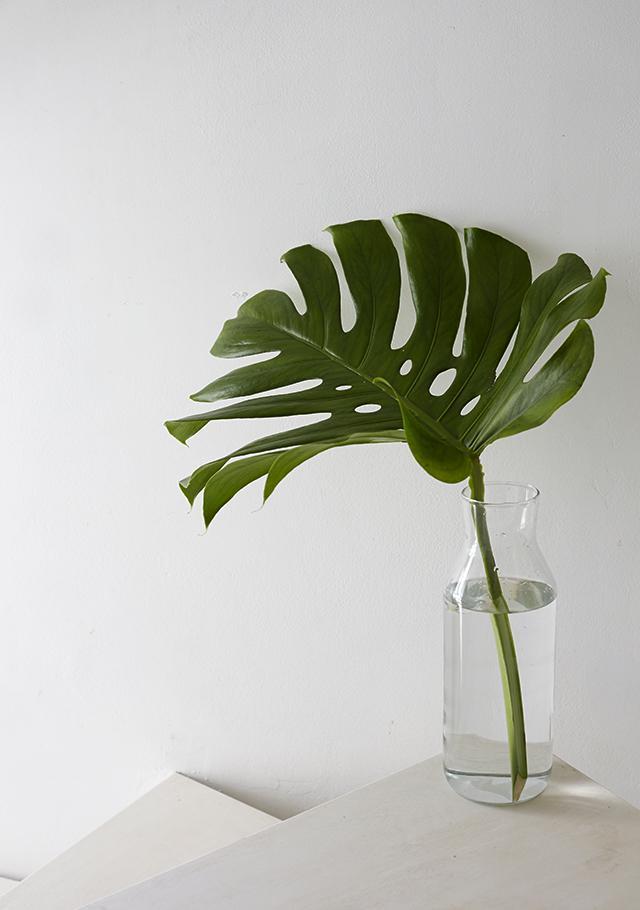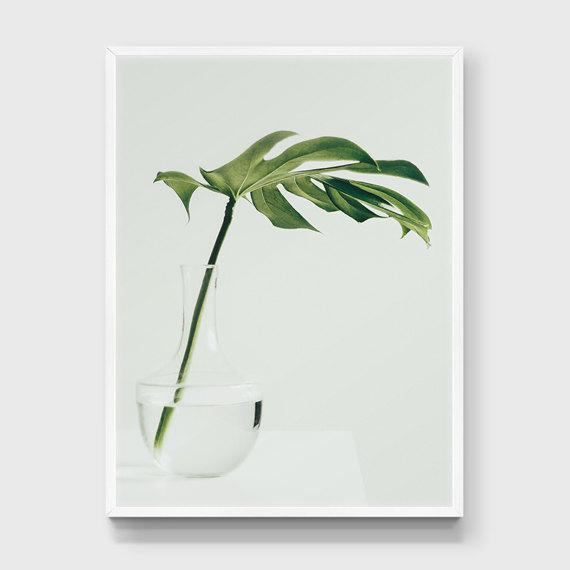The first image is the image on the left, the second image is the image on the right. Assess this claim about the two images: "The left image shows a vase containing only water and multiple leaves, and the right image features a vase with something besides water or a leaf in it.". Correct or not? Answer yes or no. No. The first image is the image on the left, the second image is the image on the right. Examine the images to the left and right. Is the description "In one of the images the plant is in a vase with only water." accurate? Answer yes or no. No. 